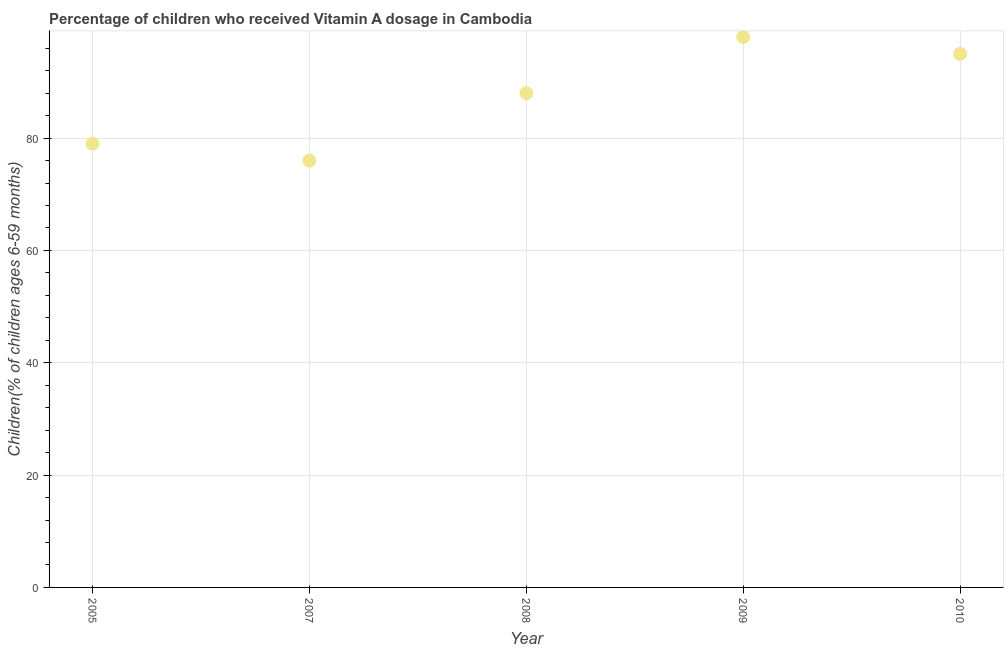What is the vitamin a supplementation coverage rate in 2010?
Ensure brevity in your answer.  95. Across all years, what is the maximum vitamin a supplementation coverage rate?
Keep it short and to the point. 98. Across all years, what is the minimum vitamin a supplementation coverage rate?
Offer a terse response. 76. In which year was the vitamin a supplementation coverage rate minimum?
Provide a short and direct response. 2007. What is the sum of the vitamin a supplementation coverage rate?
Your response must be concise. 436. What is the difference between the vitamin a supplementation coverage rate in 2005 and 2009?
Your answer should be compact. -19. What is the average vitamin a supplementation coverage rate per year?
Ensure brevity in your answer.  87.2. In how many years, is the vitamin a supplementation coverage rate greater than 12 %?
Provide a short and direct response. 5. What is the ratio of the vitamin a supplementation coverage rate in 2005 to that in 2007?
Offer a very short reply. 1.04. Is the vitamin a supplementation coverage rate in 2005 less than that in 2008?
Give a very brief answer. Yes. What is the difference between the highest and the second highest vitamin a supplementation coverage rate?
Give a very brief answer. 3. What is the difference between the highest and the lowest vitamin a supplementation coverage rate?
Provide a short and direct response. 22. How many dotlines are there?
Ensure brevity in your answer.  1. How many years are there in the graph?
Your answer should be very brief. 5. What is the difference between two consecutive major ticks on the Y-axis?
Offer a terse response. 20. Does the graph contain any zero values?
Your answer should be very brief. No. What is the title of the graph?
Your answer should be very brief. Percentage of children who received Vitamin A dosage in Cambodia. What is the label or title of the Y-axis?
Offer a very short reply. Children(% of children ages 6-59 months). What is the Children(% of children ages 6-59 months) in 2005?
Offer a terse response. 79. What is the Children(% of children ages 6-59 months) in 2007?
Keep it short and to the point. 76. What is the Children(% of children ages 6-59 months) in 2009?
Offer a terse response. 98. What is the Children(% of children ages 6-59 months) in 2010?
Keep it short and to the point. 95. What is the difference between the Children(% of children ages 6-59 months) in 2005 and 2008?
Give a very brief answer. -9. What is the difference between the Children(% of children ages 6-59 months) in 2008 and 2009?
Offer a terse response. -10. What is the ratio of the Children(% of children ages 6-59 months) in 2005 to that in 2007?
Keep it short and to the point. 1.04. What is the ratio of the Children(% of children ages 6-59 months) in 2005 to that in 2008?
Your answer should be compact. 0.9. What is the ratio of the Children(% of children ages 6-59 months) in 2005 to that in 2009?
Ensure brevity in your answer.  0.81. What is the ratio of the Children(% of children ages 6-59 months) in 2005 to that in 2010?
Offer a very short reply. 0.83. What is the ratio of the Children(% of children ages 6-59 months) in 2007 to that in 2008?
Offer a terse response. 0.86. What is the ratio of the Children(% of children ages 6-59 months) in 2007 to that in 2009?
Make the answer very short. 0.78. What is the ratio of the Children(% of children ages 6-59 months) in 2008 to that in 2009?
Keep it short and to the point. 0.9. What is the ratio of the Children(% of children ages 6-59 months) in 2008 to that in 2010?
Ensure brevity in your answer.  0.93. What is the ratio of the Children(% of children ages 6-59 months) in 2009 to that in 2010?
Offer a terse response. 1.03. 